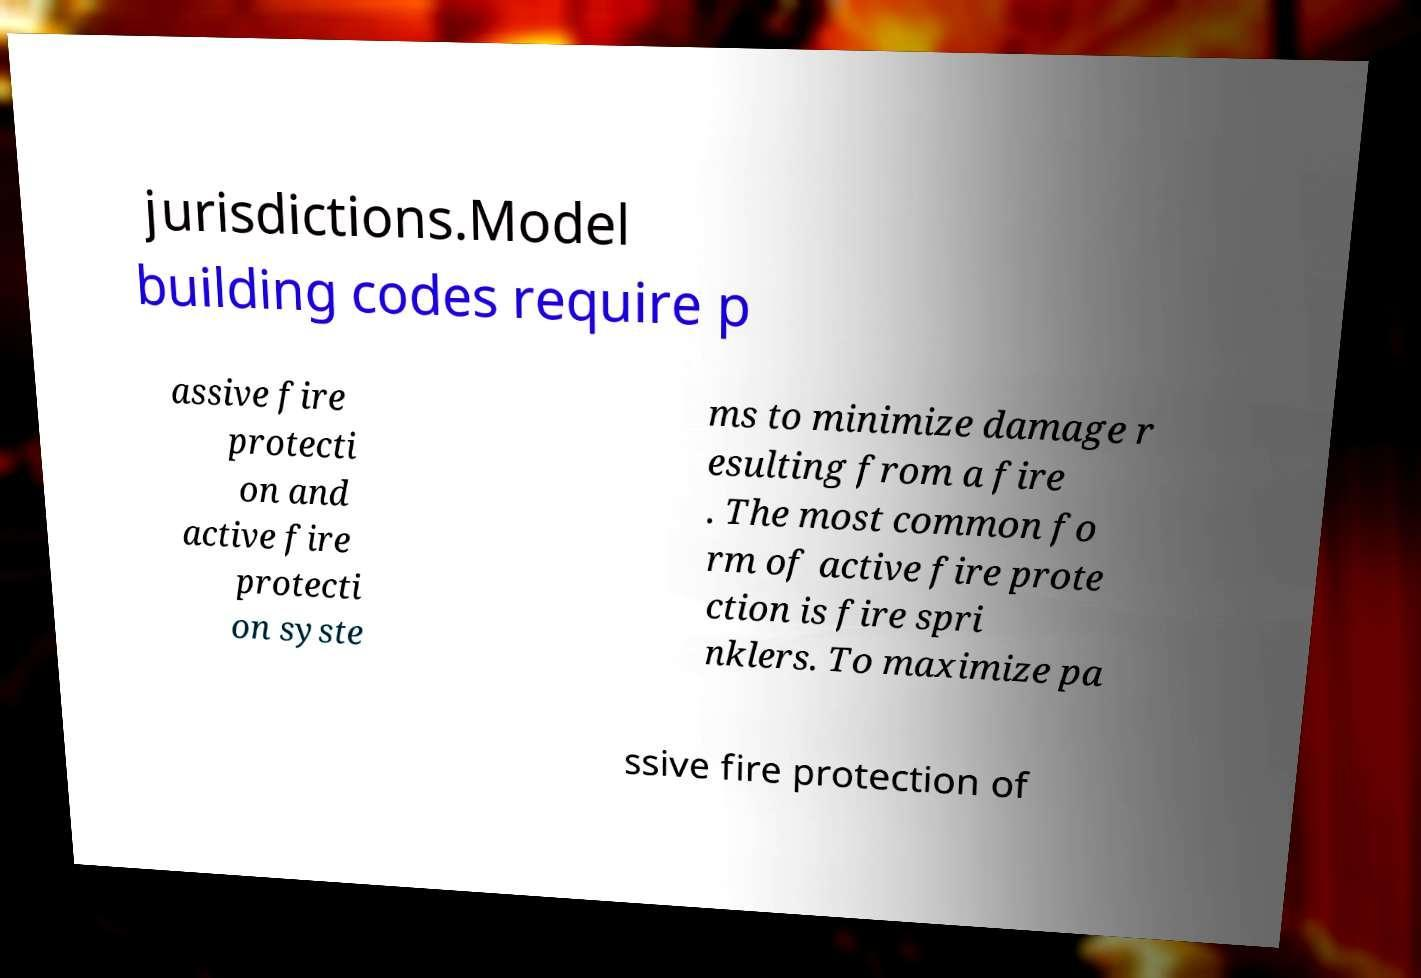There's text embedded in this image that I need extracted. Can you transcribe it verbatim? jurisdictions.Model building codes require p assive fire protecti on and active fire protecti on syste ms to minimize damage r esulting from a fire . The most common fo rm of active fire prote ction is fire spri nklers. To maximize pa ssive fire protection of 